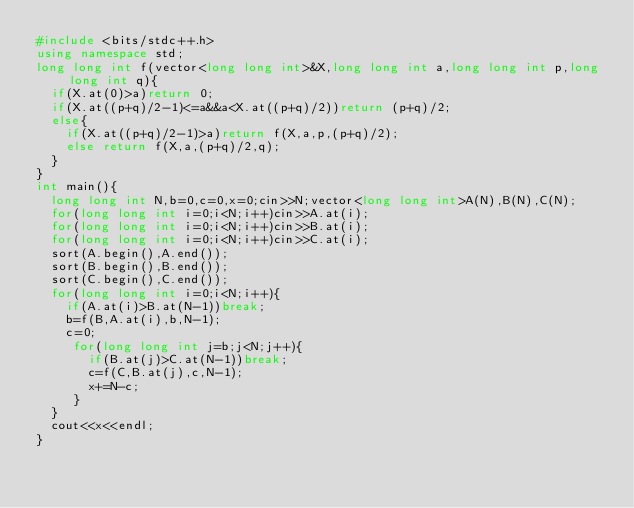<code> <loc_0><loc_0><loc_500><loc_500><_C++_>#include <bits/stdc++.h>
using namespace std;
long long int f(vector<long long int>&X,long long int a,long long int p,long long int q){
  if(X.at(0)>a)return 0;
  if(X.at((p+q)/2-1)<=a&&a<X.at((p+q)/2))return (p+q)/2;
  else{
    if(X.at((p+q)/2-1)>a)return f(X,a,p,(p+q)/2);
    else return f(X,a,(p+q)/2,q);
  }
}
int main(){
  long long int N,b=0,c=0,x=0;cin>>N;vector<long long int>A(N),B(N),C(N);
  for(long long int i=0;i<N;i++)cin>>A.at(i);
  for(long long int i=0;i<N;i++)cin>>B.at(i);
  for(long long int i=0;i<N;i++)cin>>C.at(i);
  sort(A.begin(),A.end());
  sort(B.begin(),B.end());
  sort(C.begin(),C.end());
  for(long long int i=0;i<N;i++){
    if(A.at(i)>B.at(N-1))break;
    b=f(B,A.at(i),b,N-1);
    c=0;
     for(long long int j=b;j<N;j++){
       if(B.at(j)>C.at(N-1))break;
       c=f(C,B.at(j),c,N-1);
       x+=N-c;
     }
  }
  cout<<x<<endl;
}</code> 